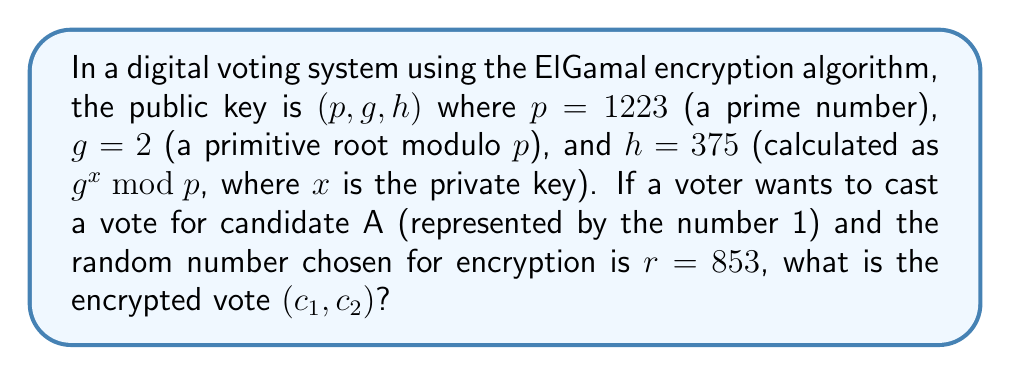Teach me how to tackle this problem. To encrypt a vote using the ElGamal algorithm, we need to follow these steps:

1. Calculate $c_1 = g^r \bmod p$
   $c_1 = 2^{853} \bmod 1223$
   
   To efficiently compute this large exponentiation, we can use the square-and-multiply algorithm:
   $2^{853} = 2^{1101010101_2}$
   $= ((((((2^2)^2 \cdot 2)^2)^2 \cdot 2)^2 \cdot 2)^2)^2 \cdot 2 \bmod 1223$
   $= 1001$

2. Calculate $c_2 = mh^r \bmod p$, where $m = 1$ (representing candidate A)
   $c_2 = 1 \cdot 375^{853} \bmod 1223$
   
   Again, using the square-and-multiply algorithm:
   $375^{853} = 375^{1101010101_2}$
   $= ((((((375^2)^2 \cdot 375)^2)^2 \cdot 375)^2 \cdot 375)^2)^2 \cdot 375 \bmod 1223$
   $= 38$

Therefore, the encrypted vote is $(c_1, c_2) = (1001, 38)$.
Answer: $(1001, 38)$ 